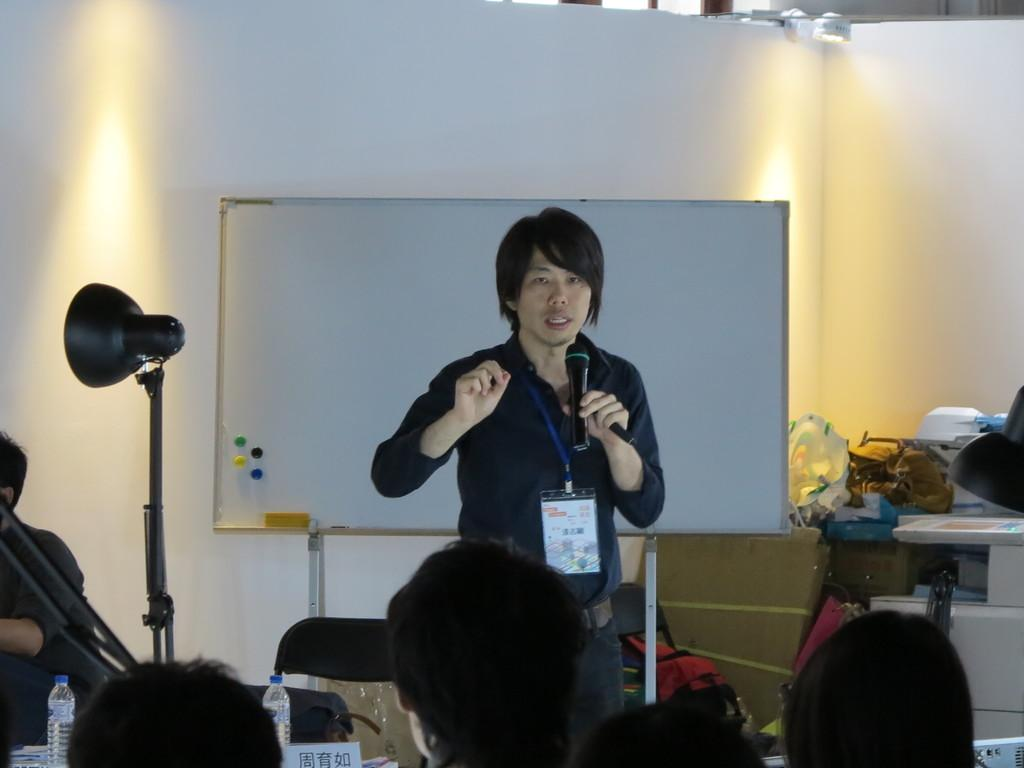What is the person holding in the image? The person is holding a mic and a wire ID card. What can be seen in the image that might provide illumination? There are lights in the image. How many people are visible in the image? There are people in the image. What type of furniture is present in the image? There are chairs in the image. What type of beverage containers are visible in the image? There are bottles in the image. What type of surface is present in the image for placing objects? There is a table in the image. What is on the table in the image? There are things on the table. What type of amusement is the person providing in the image? The image does not provide information about the person providing amusement. How does the person's digestion appear to be in the image? The image does not provide information about the person's digestion. 